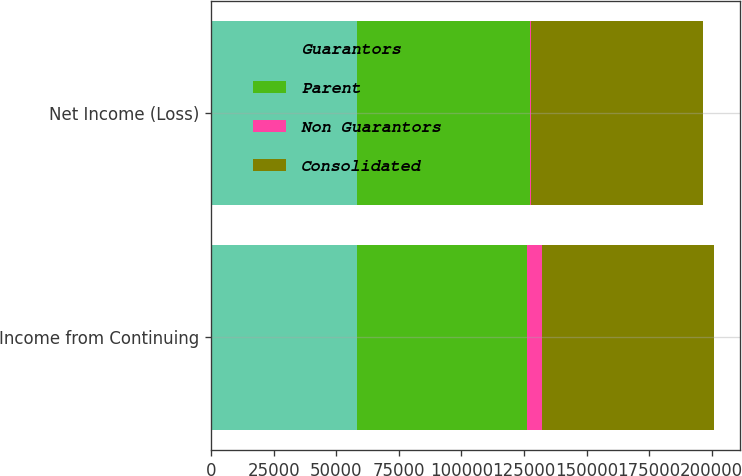Convert chart to OTSL. <chart><loc_0><loc_0><loc_500><loc_500><stacked_bar_chart><ecel><fcel>Income from Continuing<fcel>Net Income (Loss)<nl><fcel>Guarantors<fcel>58292<fcel>58292<nl><fcel>Parent<fcel>67993<fcel>69109<nl><fcel>Non Guarantors<fcel>6071<fcel>325<nl><fcel>Consolidated<fcel>68784<fcel>68784<nl></chart> 